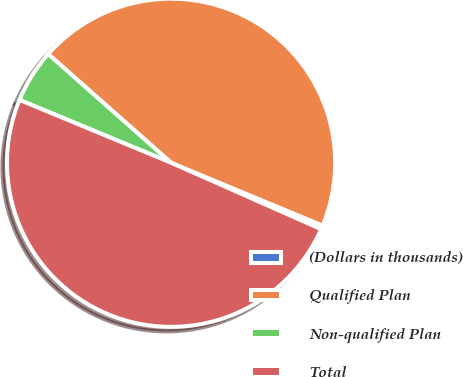Convert chart. <chart><loc_0><loc_0><loc_500><loc_500><pie_chart><fcel>(Dollars in thousands)<fcel>Qualified Plan<fcel>Non-qualified Plan<fcel>Total<nl><fcel>0.38%<fcel>44.73%<fcel>5.27%<fcel>49.62%<nl></chart> 